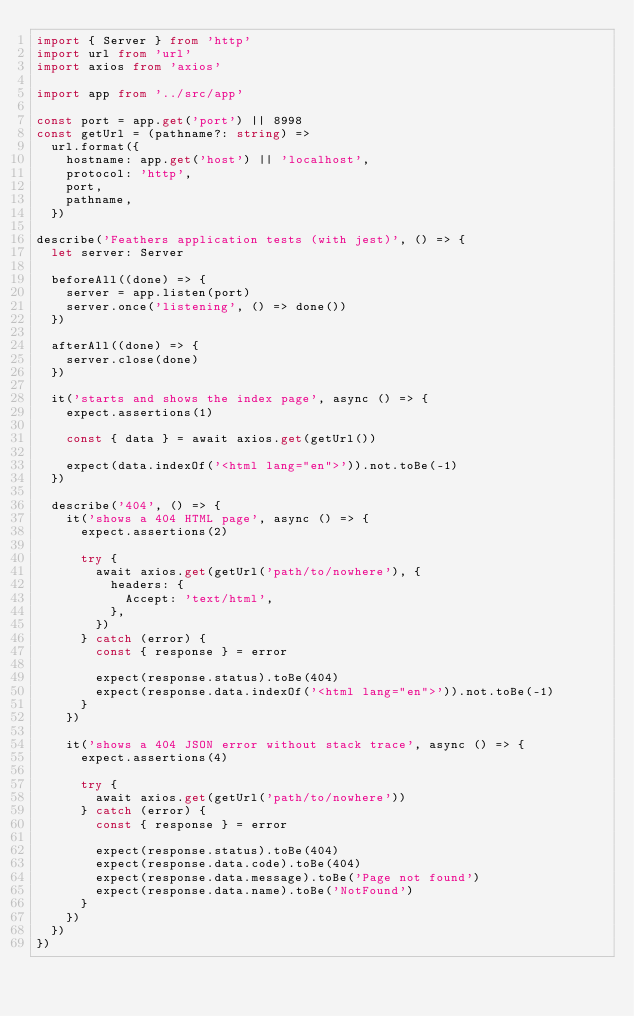Convert code to text. <code><loc_0><loc_0><loc_500><loc_500><_TypeScript_>import { Server } from 'http'
import url from 'url'
import axios from 'axios'

import app from '../src/app'

const port = app.get('port') || 8998
const getUrl = (pathname?: string) =>
  url.format({
    hostname: app.get('host') || 'localhost',
    protocol: 'http',
    port,
    pathname,
  })

describe('Feathers application tests (with jest)', () => {
  let server: Server

  beforeAll((done) => {
    server = app.listen(port)
    server.once('listening', () => done())
  })

  afterAll((done) => {
    server.close(done)
  })

  it('starts and shows the index page', async () => {
    expect.assertions(1)

    const { data } = await axios.get(getUrl())

    expect(data.indexOf('<html lang="en">')).not.toBe(-1)
  })

  describe('404', () => {
    it('shows a 404 HTML page', async () => {
      expect.assertions(2)

      try {
        await axios.get(getUrl('path/to/nowhere'), {
          headers: {
            Accept: 'text/html',
          },
        })
      } catch (error) {
        const { response } = error

        expect(response.status).toBe(404)
        expect(response.data.indexOf('<html lang="en">')).not.toBe(-1)
      }
    })

    it('shows a 404 JSON error without stack trace', async () => {
      expect.assertions(4)

      try {
        await axios.get(getUrl('path/to/nowhere'))
      } catch (error) {
        const { response } = error

        expect(response.status).toBe(404)
        expect(response.data.code).toBe(404)
        expect(response.data.message).toBe('Page not found')
        expect(response.data.name).toBe('NotFound')
      }
    })
  })
})
</code> 